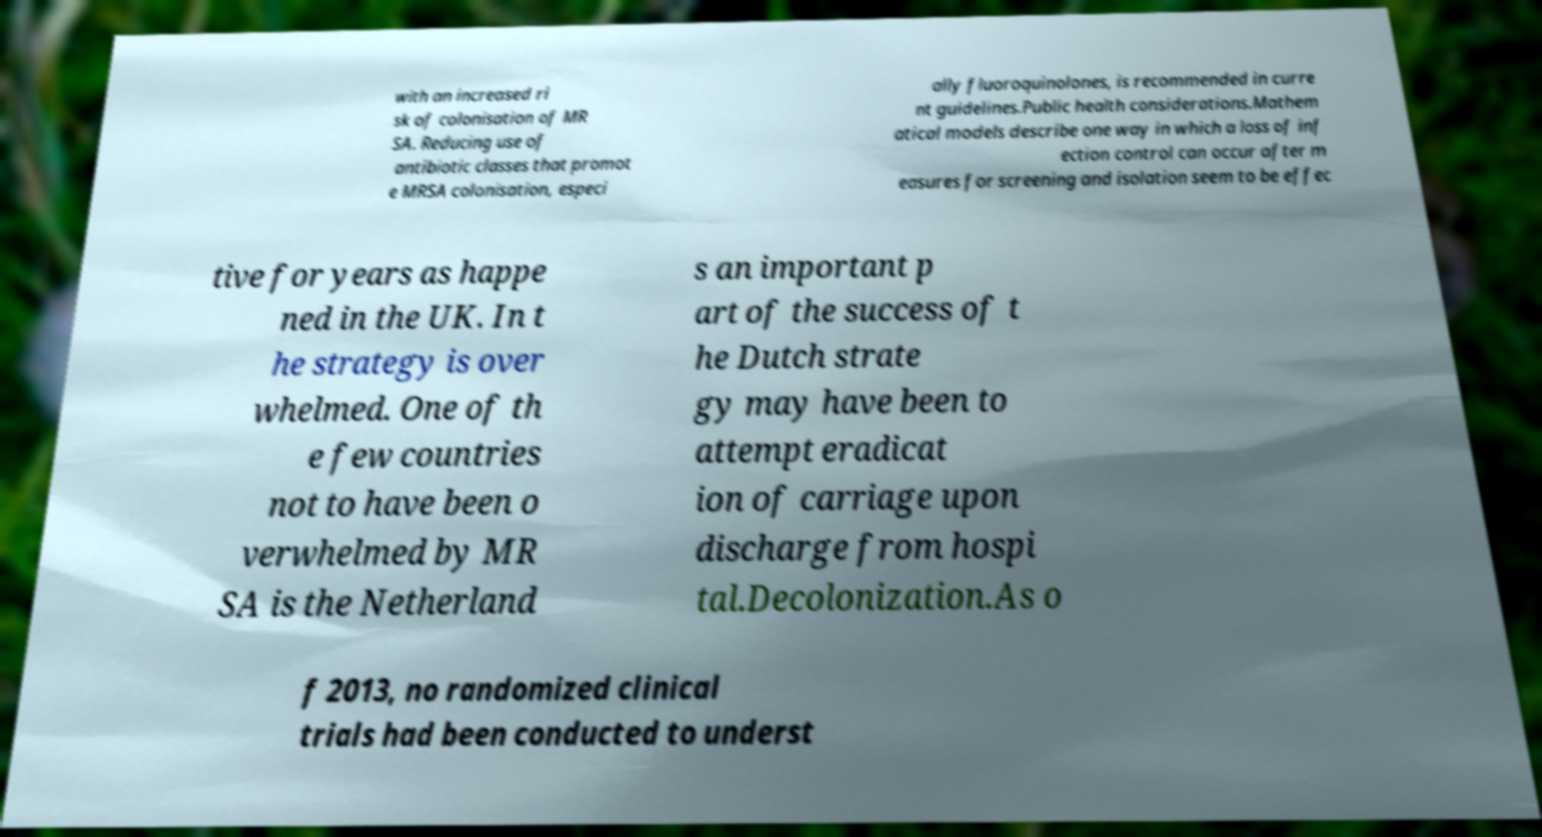Could you assist in decoding the text presented in this image and type it out clearly? with an increased ri sk of colonisation of MR SA. Reducing use of antibiotic classes that promot e MRSA colonisation, especi ally fluoroquinolones, is recommended in curre nt guidelines.Public health considerations.Mathem atical models describe one way in which a loss of inf ection control can occur after m easures for screening and isolation seem to be effec tive for years as happe ned in the UK. In t he strategy is over whelmed. One of th e few countries not to have been o verwhelmed by MR SA is the Netherland s an important p art of the success of t he Dutch strate gy may have been to attempt eradicat ion of carriage upon discharge from hospi tal.Decolonization.As o f 2013, no randomized clinical trials had been conducted to underst 